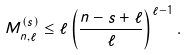Convert formula to latex. <formula><loc_0><loc_0><loc_500><loc_500>M _ { n , \ell } ^ { ( s ) } \leq \ell \left ( \frac { n - s + \ell } { \ell } \right ) ^ { \ell - 1 } .</formula> 